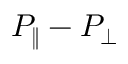<formula> <loc_0><loc_0><loc_500><loc_500>P _ { \| } - P _ { \perp }</formula> 